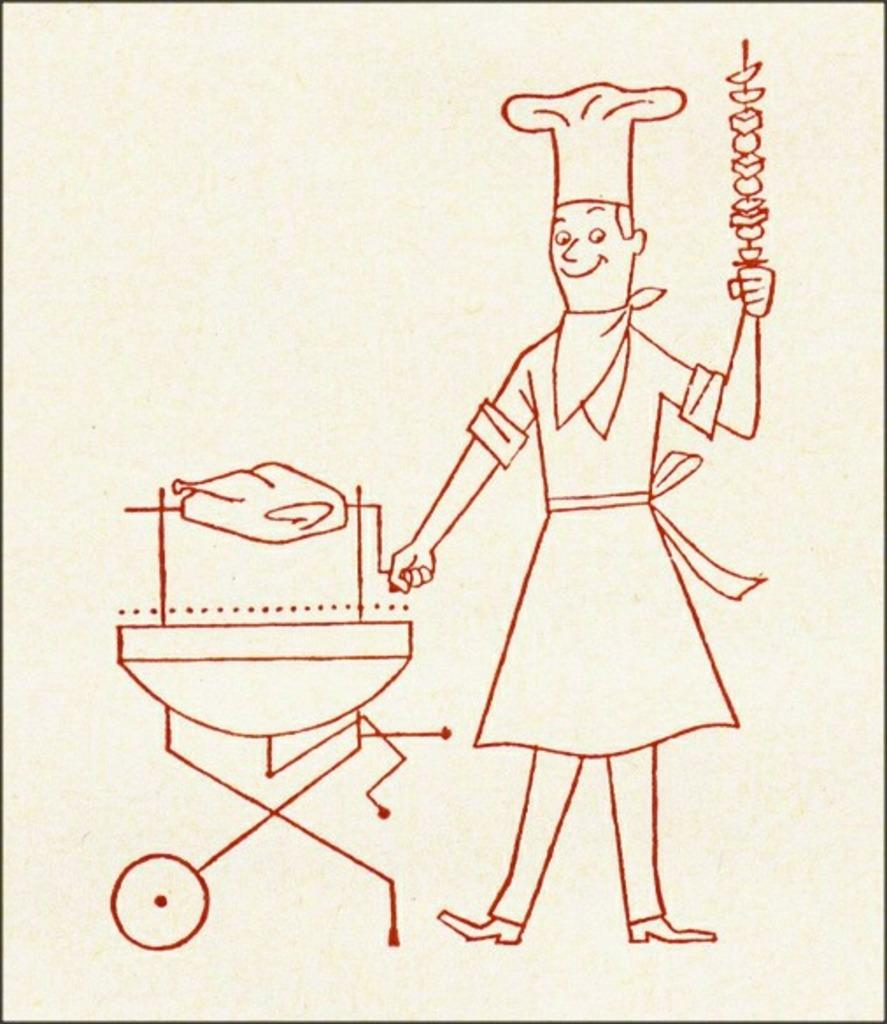What type of visual is the image? The image is a poster. What is featured on the poster? There is a drawing on the poster. Can you describe the content of the drawing? The drawing depicts a person holding objects. What is the person wearing in the drawing? The person is wearing a cap in the drawing. How many geese are flying in the drawing on the poster? There are no geese depicted in the drawing on the poster. What type of lamp is featured in the drawing on the poster? There is no lamp present in the drawing on the poster. 